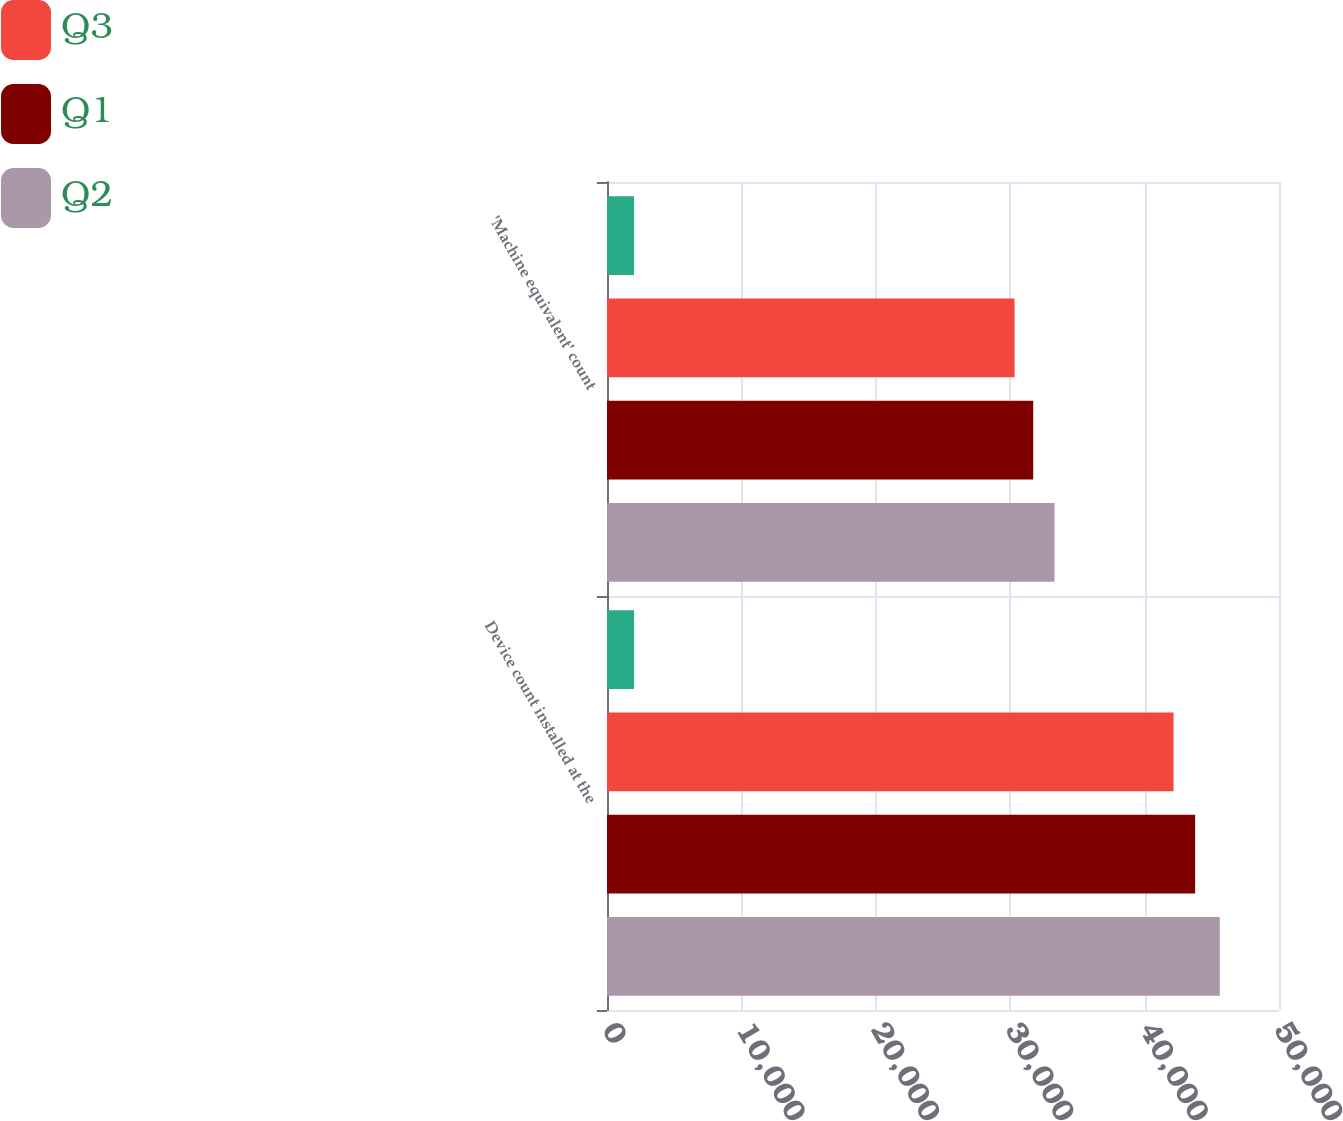Convert chart. <chart><loc_0><loc_0><loc_500><loc_500><stacked_bar_chart><ecel><fcel>Device count installed at the<fcel>'Machine equivalent' count<nl><fcel>nan<fcel>2014<fcel>2014<nl><fcel>Q3<fcel>42153<fcel>30326<nl><fcel>Q1<fcel>43761<fcel>31713<nl><fcel>Q2<fcel>45596<fcel>33296<nl></chart> 